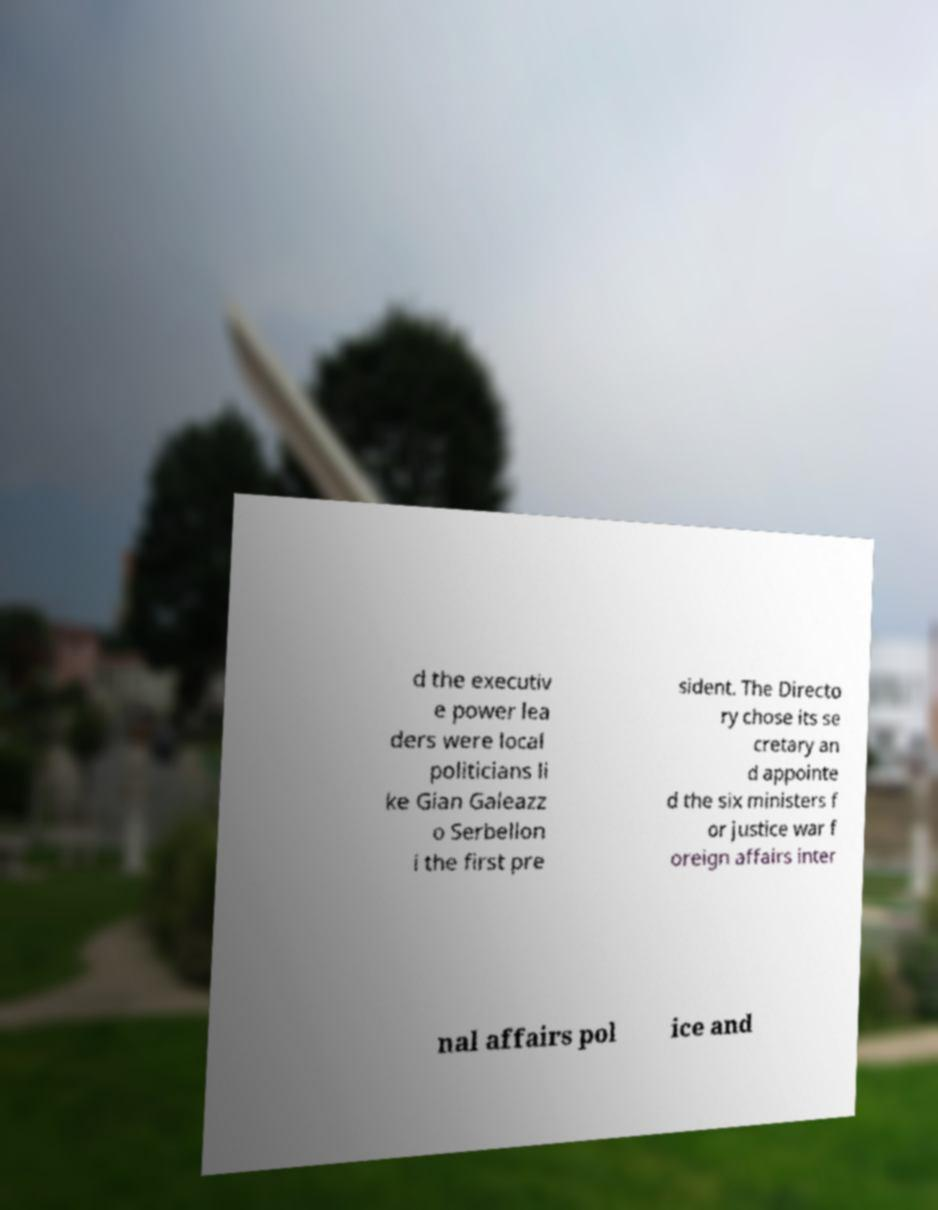Can you accurately transcribe the text from the provided image for me? d the executiv e power lea ders were local politicians li ke Gian Galeazz o Serbellon i the first pre sident. The Directo ry chose its se cretary an d appointe d the six ministers f or justice war f oreign affairs inter nal affairs pol ice and 